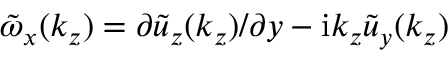Convert formula to latex. <formula><loc_0><loc_0><loc_500><loc_500>\tilde { \omega } _ { x } ( k _ { z } ) = \partial \tilde { u } _ { z } ( k _ { z } ) / \partial y - i k _ { z } \tilde { u } _ { y } ( k _ { z } )</formula> 